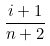Convert formula to latex. <formula><loc_0><loc_0><loc_500><loc_500>\frac { i + 1 } { n + 2 }</formula> 